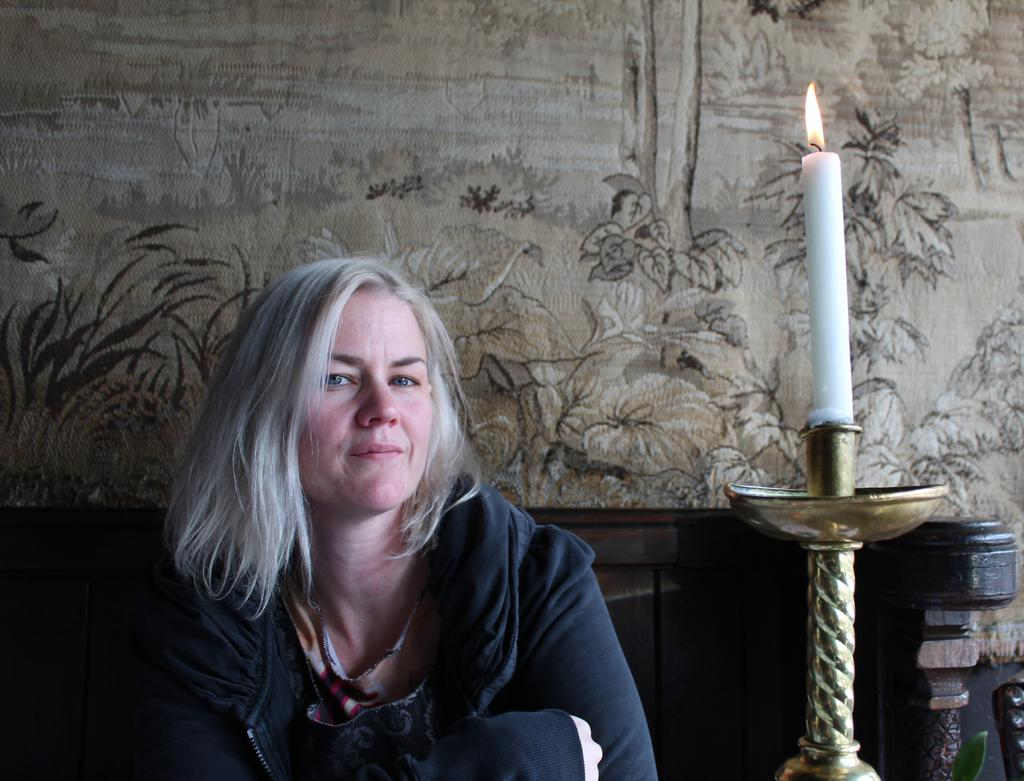Who is present in the image? There is a lady in the image. What object can be seen with a flame in the image? There is a candle with a flame on a stand in the image. What can be seen on the wall in the background of the image? There is a wall with a design in the background of the image. How many chickens are present in the image? There are no chickens present in the image. What type of steel is used to make the candle stand? The image does not provide information about the material used to make the candle stand, so it cannot be determined from the image. 